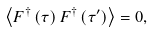Convert formula to latex. <formula><loc_0><loc_0><loc_500><loc_500>\left \langle F ^ { \dagger } \left ( \tau \right ) F ^ { \dagger } \left ( \tau ^ { \prime } \right ) \right \rangle = 0 ,</formula> 